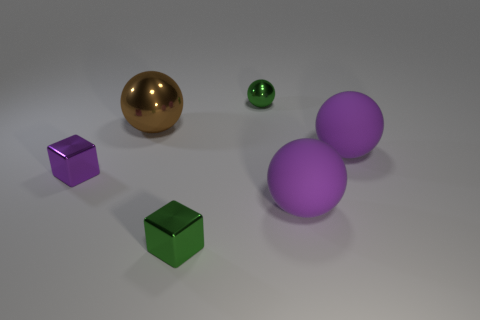Subtract all green metal spheres. How many spheres are left? 3 Subtract 1 blocks. How many blocks are left? 1 Add 1 small green metal balls. How many objects exist? 7 Subtract all purple spheres. How many spheres are left? 2 Subtract all blocks. How many objects are left? 4 Subtract all gray balls. Subtract all green cylinders. How many balls are left? 4 Subtract all brown balls. How many gray cubes are left? 0 Subtract all big metal objects. Subtract all big purple metallic things. How many objects are left? 5 Add 6 green balls. How many green balls are left? 7 Add 5 small purple things. How many small purple things exist? 6 